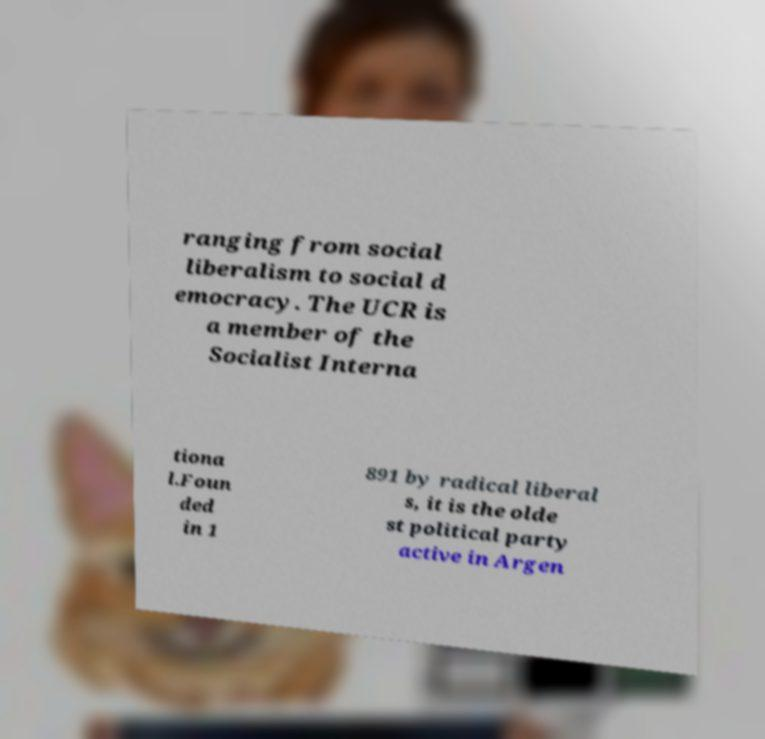For documentation purposes, I need the text within this image transcribed. Could you provide that? ranging from social liberalism to social d emocracy. The UCR is a member of the Socialist Interna tiona l.Foun ded in 1 891 by radical liberal s, it is the olde st political party active in Argen 